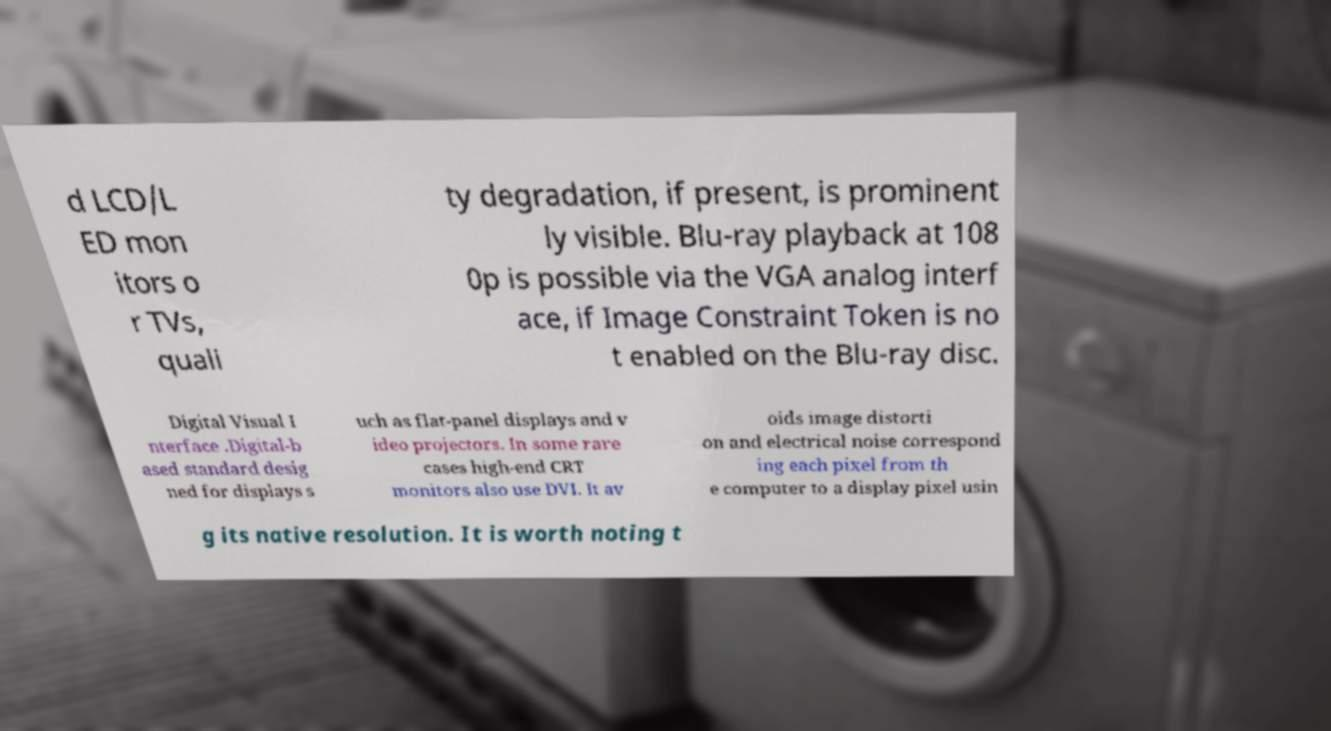Can you accurately transcribe the text from the provided image for me? d LCD/L ED mon itors o r TVs, quali ty degradation, if present, is prominent ly visible. Blu-ray playback at 108 0p is possible via the VGA analog interf ace, if Image Constraint Token is no t enabled on the Blu-ray disc. Digital Visual I nterface .Digital-b ased standard desig ned for displays s uch as flat-panel displays and v ideo projectors. In some rare cases high-end CRT monitors also use DVI. It av oids image distorti on and electrical noise correspond ing each pixel from th e computer to a display pixel usin g its native resolution. It is worth noting t 